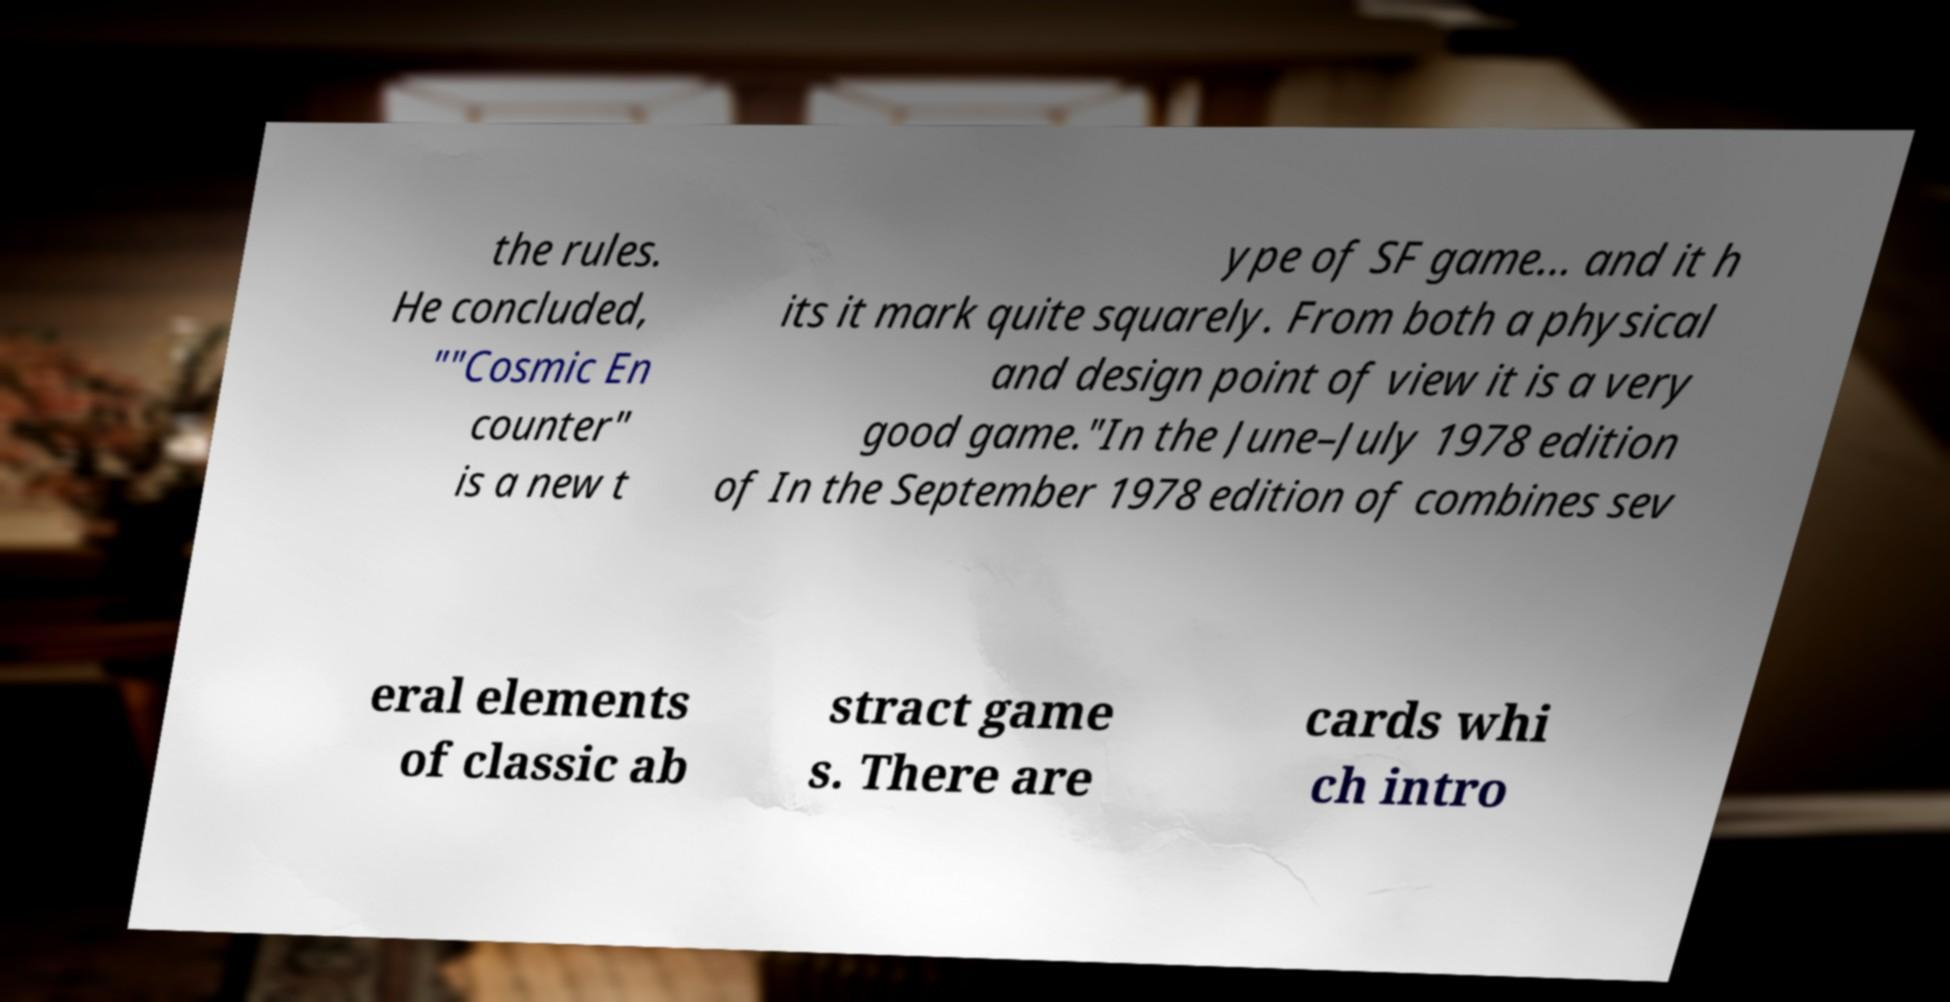Could you assist in decoding the text presented in this image and type it out clearly? the rules. He concluded, ""Cosmic En counter" is a new t ype of SF game... and it h its it mark quite squarely. From both a physical and design point of view it is a very good game."In the June–July 1978 edition of In the September 1978 edition of combines sev eral elements of classic ab stract game s. There are cards whi ch intro 